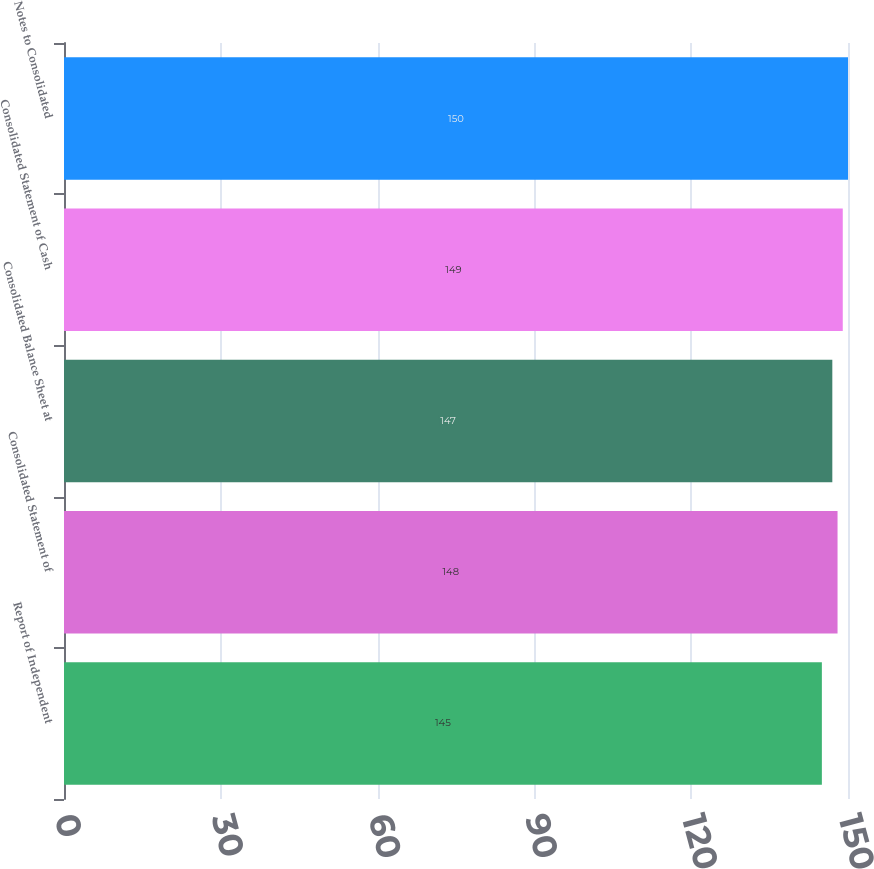Convert chart. <chart><loc_0><loc_0><loc_500><loc_500><bar_chart><fcel>Report of Independent<fcel>Consolidated Statement of<fcel>Consolidated Balance Sheet at<fcel>Consolidated Statement of Cash<fcel>Notes to Consolidated<nl><fcel>145<fcel>148<fcel>147<fcel>149<fcel>150<nl></chart> 